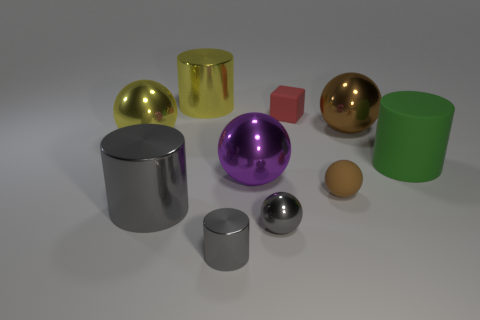How many things are large shiny balls that are to the left of the tiny brown ball or small matte cubes?
Make the answer very short. 3. What material is the big green object?
Your answer should be very brief. Rubber. Is the size of the green cylinder the same as the yellow cylinder?
Provide a succinct answer. Yes. What number of cubes are either large gray metal things or small rubber things?
Your answer should be compact. 1. What is the color of the big cylinder that is behind the big metallic thing on the right side of the small rubber sphere?
Provide a short and direct response. Yellow. Is the number of big green cylinders that are in front of the big green cylinder less than the number of large cylinders that are left of the gray sphere?
Offer a very short reply. Yes. There is a yellow sphere; does it have the same size as the gray metallic thing in front of the gray metal sphere?
Make the answer very short. No. The large object that is to the right of the red block and behind the green matte thing has what shape?
Your answer should be very brief. Sphere. What is the size of the yellow ball that is the same material as the small cylinder?
Offer a terse response. Large. There is a tiny metallic cylinder that is on the left side of the red matte object; what number of big shiny things are in front of it?
Your response must be concise. 0. 